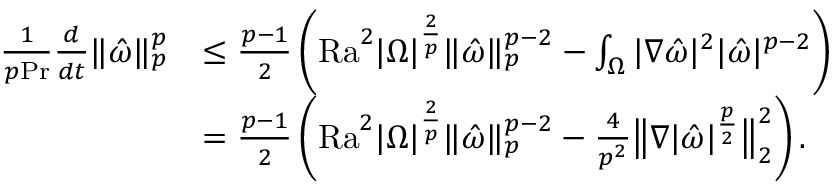Convert formula to latex. <formula><loc_0><loc_0><loc_500><loc_500>\begin{array} { r l } { \frac { 1 } { p P r } \frac { d } { d t } \| \hat { \omega } \| _ { p } ^ { p } } & { \leq \frac { p - 1 } { 2 } \left ( { R a } ^ { 2 } | \Omega | ^ { \frac { 2 } { p } } \| \hat { \omega } \| _ { p } ^ { p - 2 } - \int _ { \Omega } | \nabla \hat { \omega } | ^ { 2 } | \hat { \omega } | ^ { p - 2 } \right ) } \\ & { = \frac { p - 1 } { 2 } \left ( { R a } ^ { 2 } | \Omega | ^ { \frac { 2 } { p } } \| \hat { \omega } \| _ { p } ^ { p - 2 } - \frac { 4 } { p ^ { 2 } } \left \| \nabla | \hat { \omega } | ^ { \frac { p } { 2 } } \right \| _ { 2 } ^ { 2 } \right ) . } \end{array}</formula> 